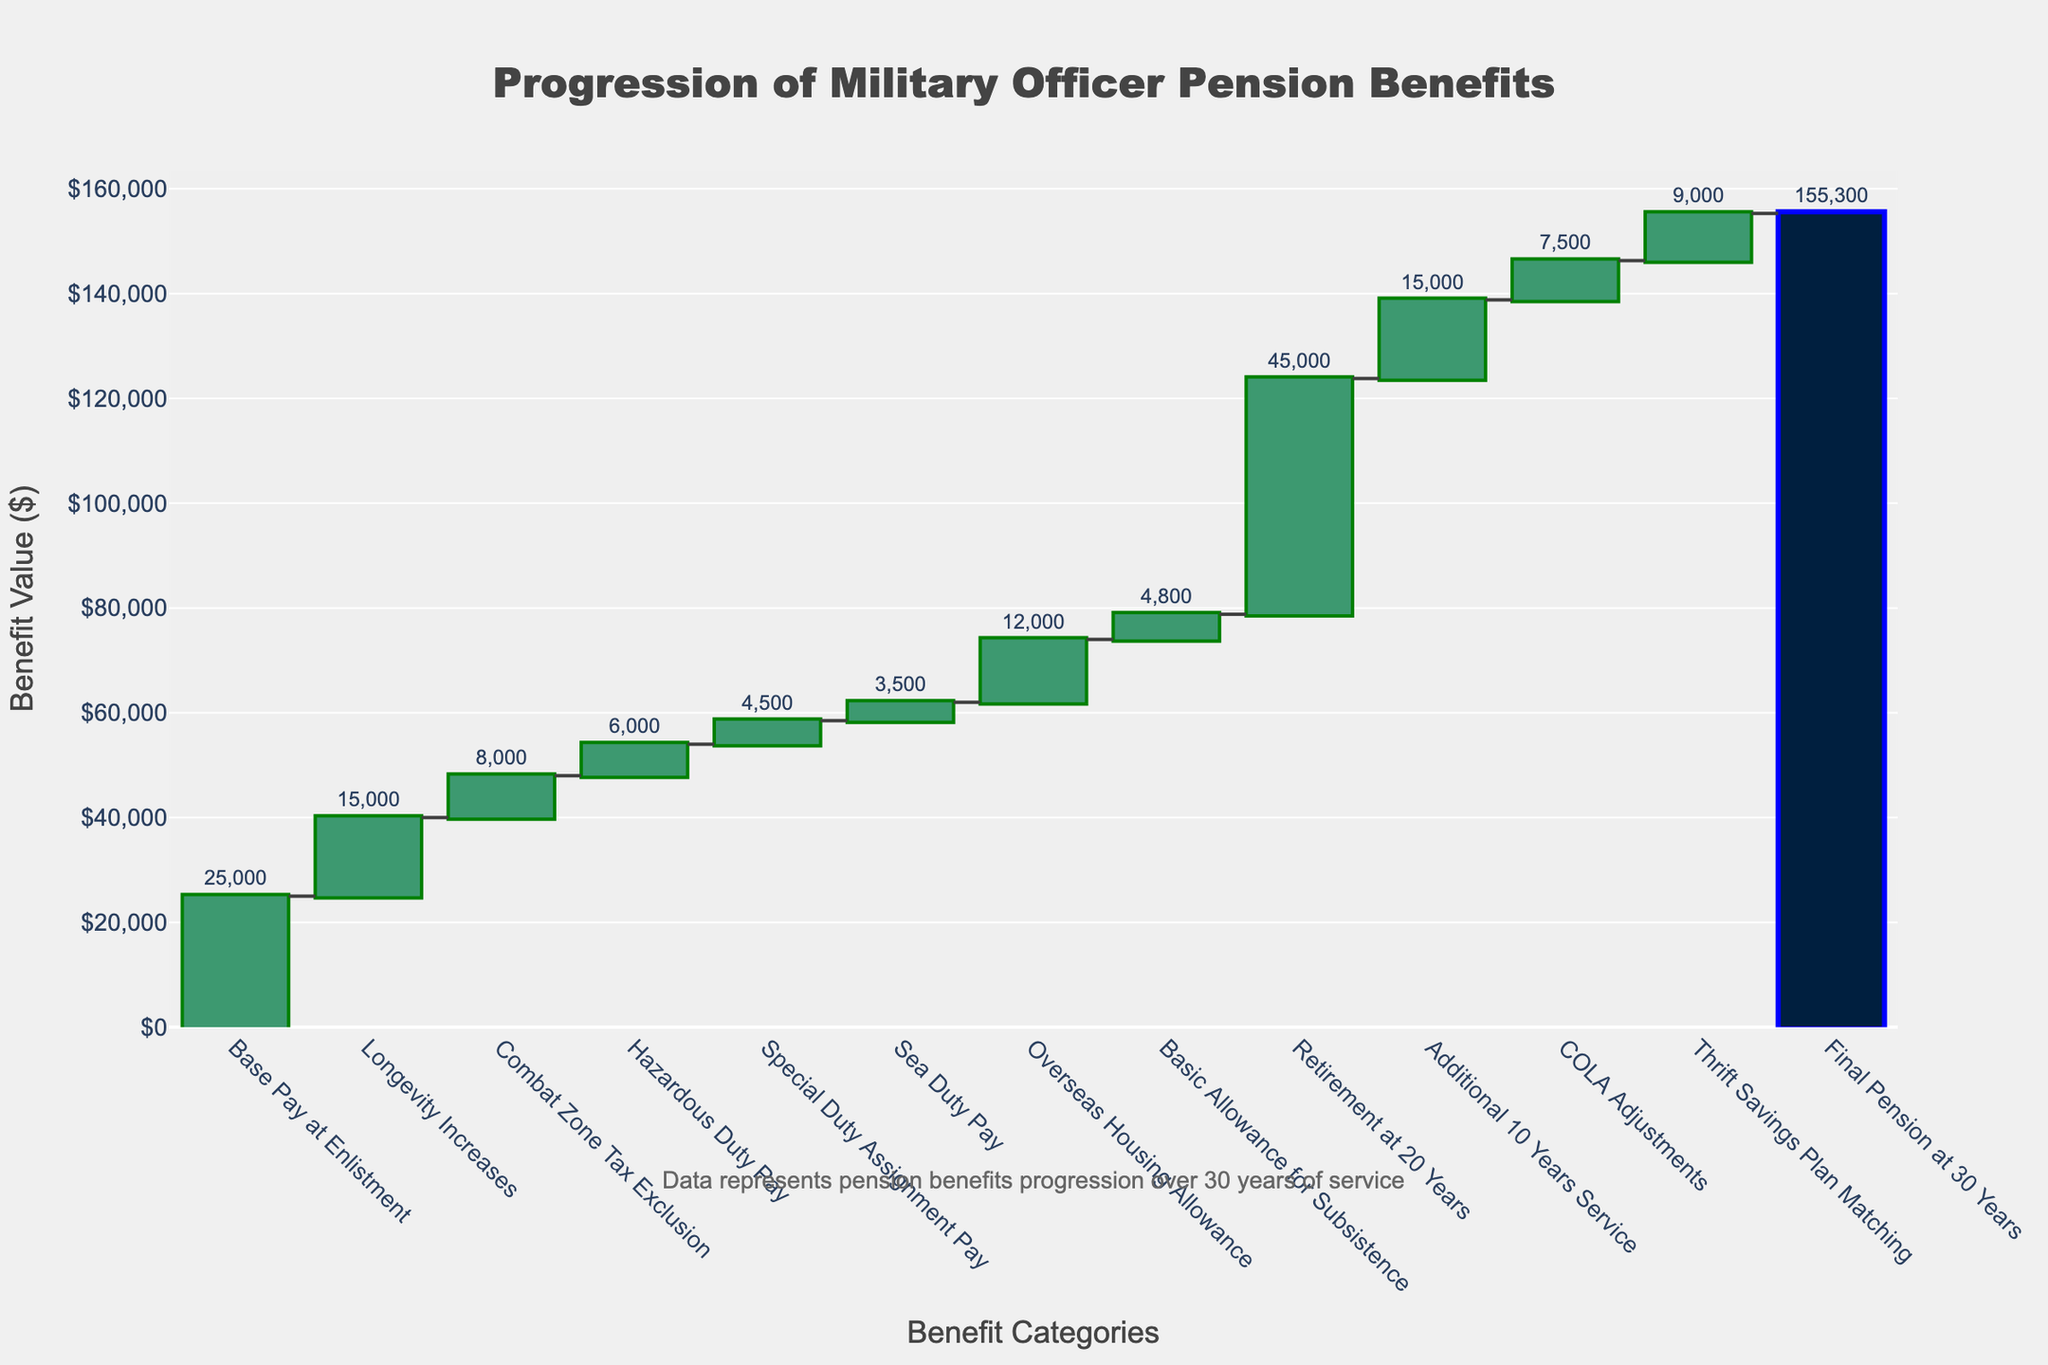What is the title of the waterfall chart? The title is displayed at the top of the chart, indicating the subject of the visualization.
Answer: Progression of Military Officer Pension Benefits Which category has the highest individual value increase? By comparing the bars, the Retirement at 20 Years category has the largest bar height, indicating the highest value.
Answer: Retirement at 20 Years What is the initial value at enlistment? The base pay value at enlistment is indicated by the first bar in the chart.
Answer: 25000 What is the total value of military officer pension benefits after 30 years of service? The total value is found at the end of the waterfall chart, represented by a large, distinct total bar.
Answer: 155300 How much does the Combat Zone Tax Exclusion add to the benefits? The value is indicated by the height of the corresponding bar in the chart labeled Combat Zone Tax Exclusion.
Answer: 8000 How many different categories contribute positively to the total value? Count the number of increasing bars in the waterfall chart.
Answer: 12 What is the cumulative value at the conclusion of the overseas housing allowance? Sum up all the values up to and including the Overseas Housing Allowance and check its position on the y-axis on the waterfall chart.
Answer: 73000 Compare the values added by Hazardous Duty Pay and Sea Duty Pay. Which one is greater? By visually comparing the heights of both bars, Hazardous Duty Pay has a taller bar compared to Sea Duty Pay.
Answer: Hazardous Duty Pay How much do COLA Adjustments add to the benefits? The value is represented by the height of the COLA Adjustments bar in the chart.
Answer: 7500 